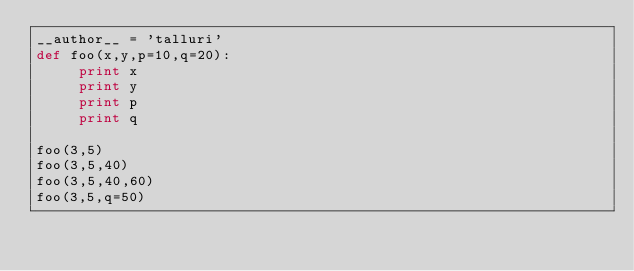Convert code to text. <code><loc_0><loc_0><loc_500><loc_500><_Python_>__author__ = 'talluri'
def foo(x,y,p=10,q=20):
     print x
     print y
     print p
     print q

foo(3,5)
foo(3,5,40)
foo(3,5,40,60)
foo(3,5,q=50)

</code> 